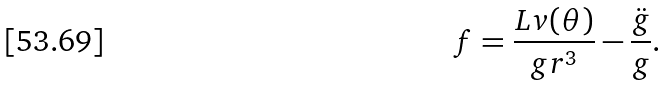<formula> <loc_0><loc_0><loc_500><loc_500>f = \frac { L v ( \theta ) } { g r ^ { 3 } } - \frac { \ddot { g } } { g } .</formula> 